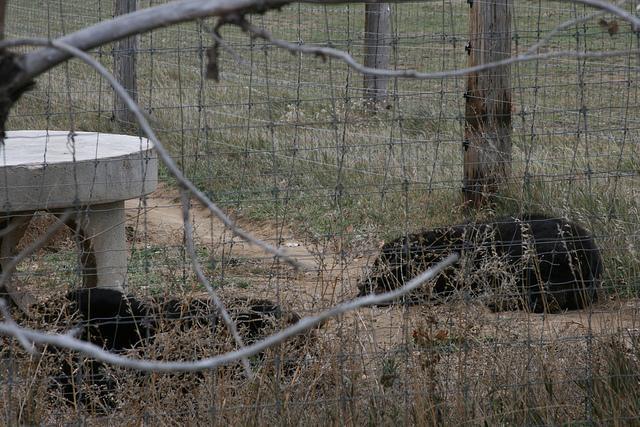How many bears are there?
Give a very brief answer. 2. How many boats are to the right of the stop sign?
Give a very brief answer. 0. 